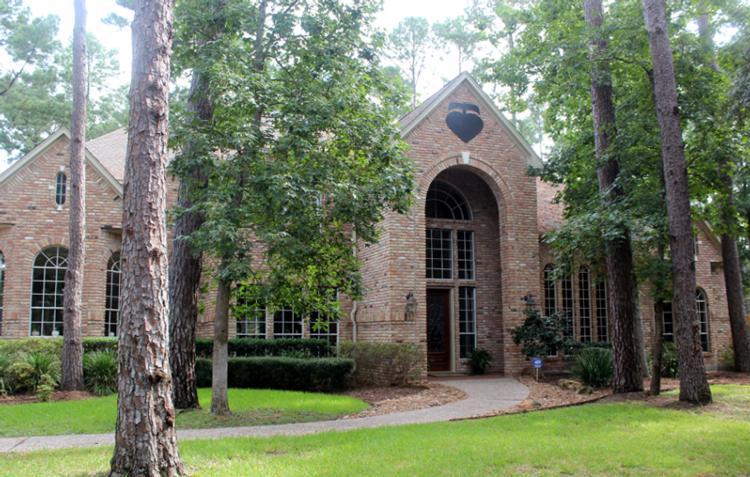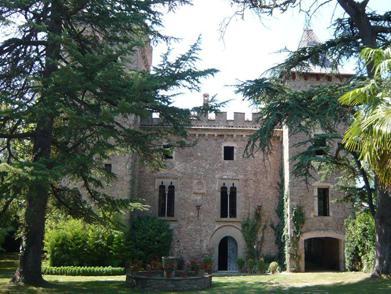The first image is the image on the left, the second image is the image on the right. Analyze the images presented: Is the assertion "There is at least one visible cross atop the building in one of the images." valid? Answer yes or no. No. The first image is the image on the left, the second image is the image on the right. For the images displayed, is the sentence "There is at least one cross atop the building in one of the images." factually correct? Answer yes or no. No. 